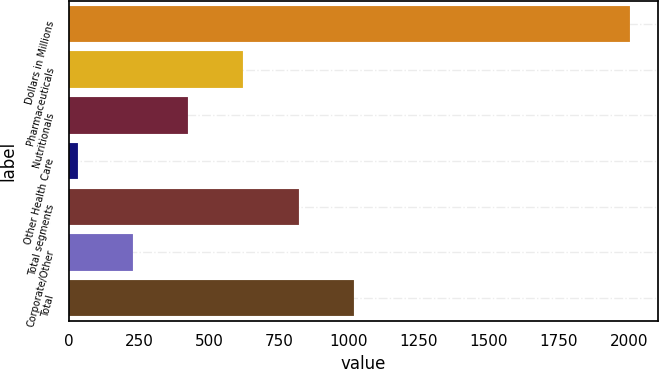<chart> <loc_0><loc_0><loc_500><loc_500><bar_chart><fcel>Dollars in Millions<fcel>Pharmaceuticals<fcel>Nutritionals<fcel>Other Health Care<fcel>Total segments<fcel>Corporate/Other<fcel>Total<nl><fcel>2005<fcel>622.5<fcel>425<fcel>30<fcel>820<fcel>227.5<fcel>1017.5<nl></chart> 